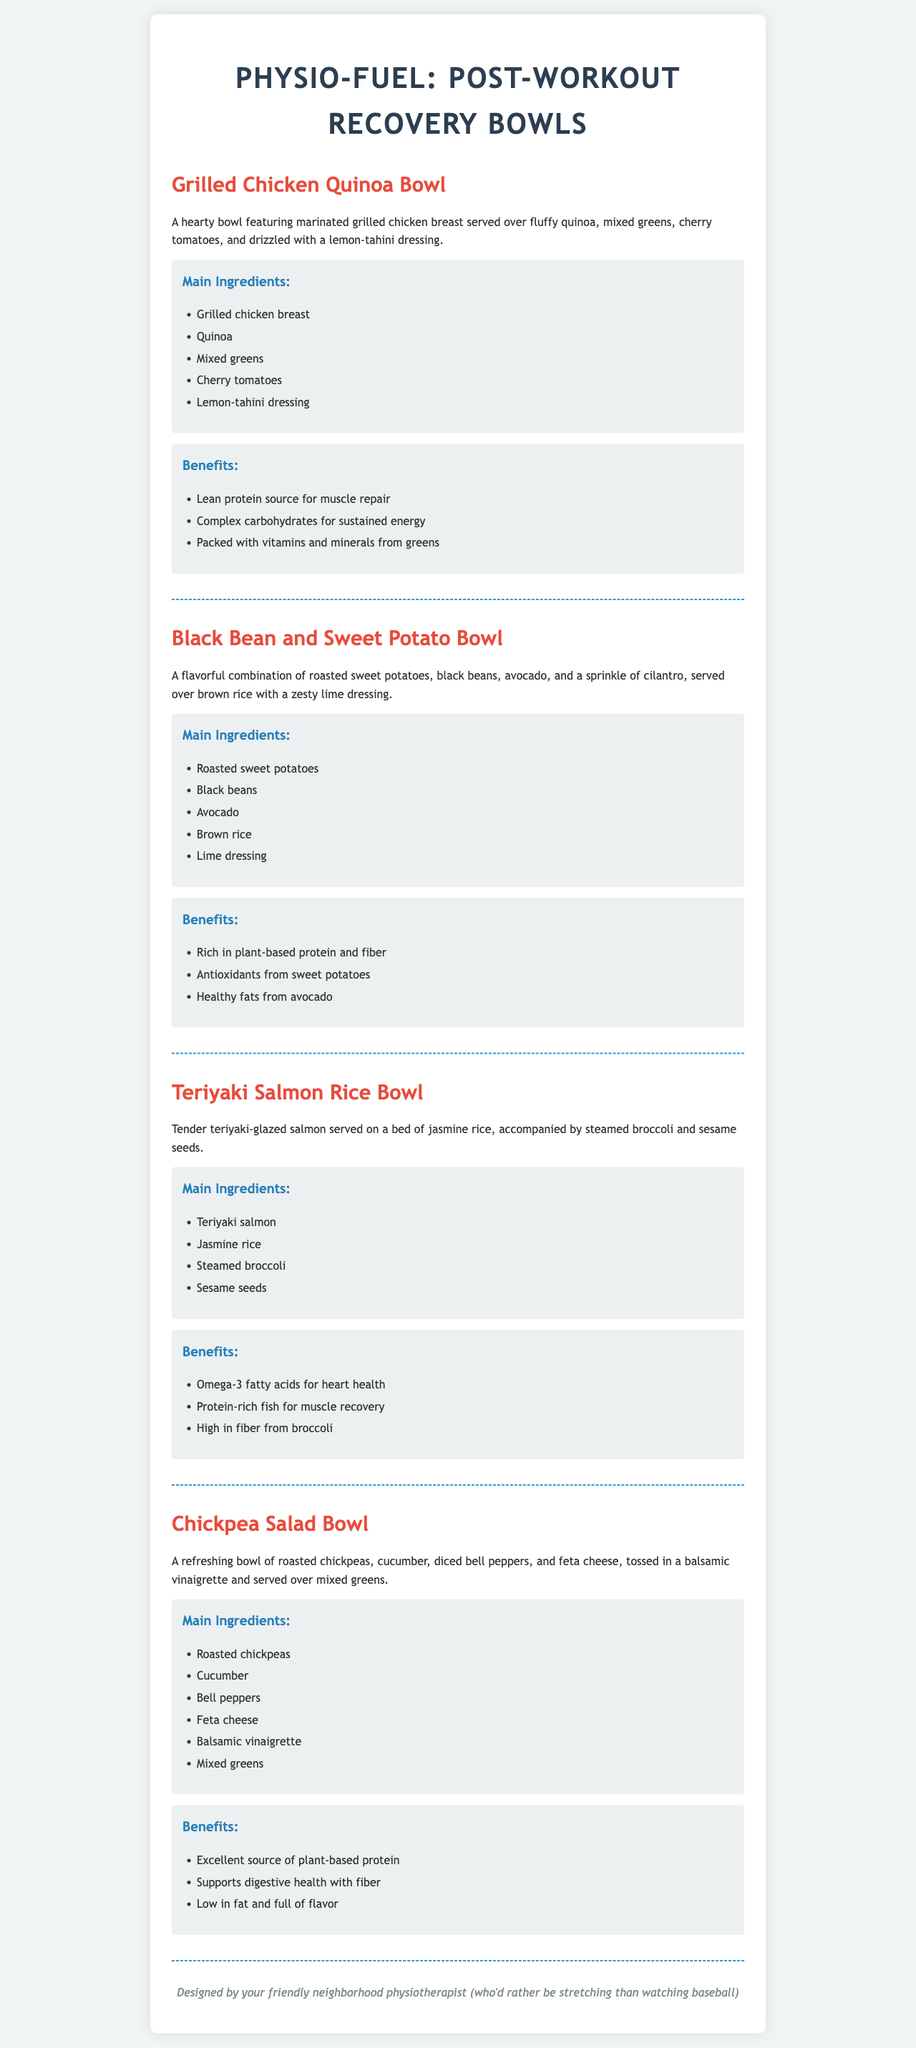What is the first bowl listed? The first bowl listed in the menu is "Grilled Chicken Quinoa Bowl."
Answer: Grilled Chicken Quinoa Bowl What dressing is used in the Grilled Chicken Quinoa Bowl? The Grilled Chicken Quinoa Bowl is drizzled with a lemon-tahini dressing.
Answer: Lemon-tahini dressing Which bowl includes omega-3 fatty acids? The bowl that includes omega-3 fatty acids is the Teriyaki Salmon Rice Bowl.
Answer: Teriyaki Salmon Rice Bowl How many main ingredients are in the Chickpea Salad Bowl? The Chickpea Salad Bowl has six main ingredients listed.
Answer: Six What type of protein is emphasized in the Black Bean and Sweet Potato Bowl? The Black Bean and Sweet Potato Bowl emphasizes plant-based protein.
Answer: Plant-based protein What is the common feature of all bowls on the menu? All bowls are designed for post-workout recovery.
Answer: Post-workout recovery Which bowl contains feta cheese? The bowl that contains feta cheese is the Chickpea Salad Bowl.
Answer: Chickpea Salad Bowl What is the base for the Teriyaki Salmon Rice Bowl? The base for the Teriyaki Salmon Rice Bowl is jasmine rice.
Answer: Jasmine rice 